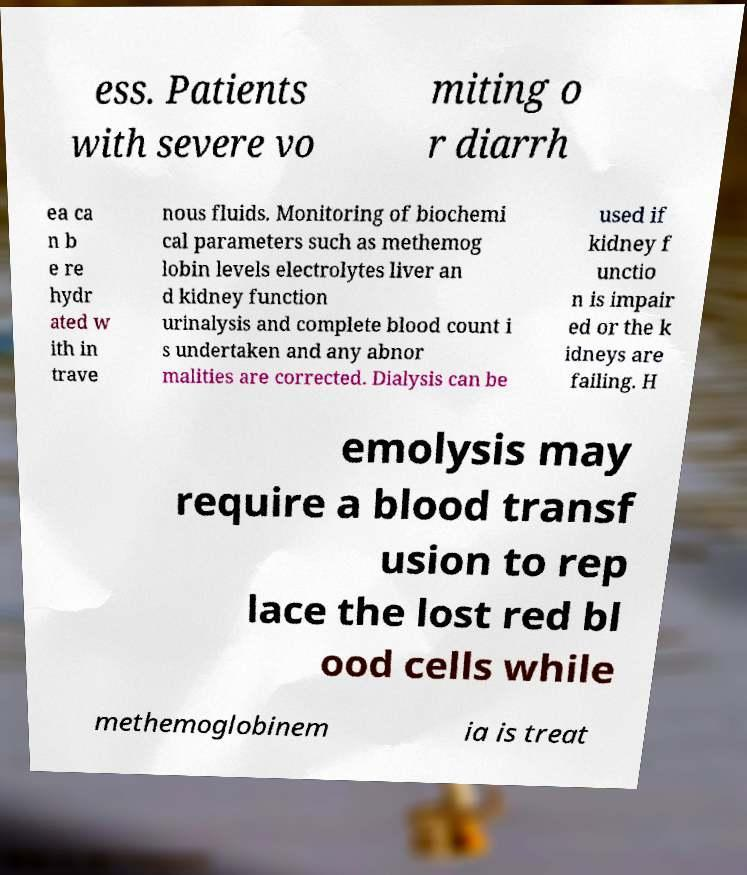What messages or text are displayed in this image? I need them in a readable, typed format. ess. Patients with severe vo miting o r diarrh ea ca n b e re hydr ated w ith in trave nous fluids. Monitoring of biochemi cal parameters such as methemog lobin levels electrolytes liver an d kidney function urinalysis and complete blood count i s undertaken and any abnor malities are corrected. Dialysis can be used if kidney f unctio n is impair ed or the k idneys are failing. H emolysis may require a blood transf usion to rep lace the lost red bl ood cells while methemoglobinem ia is treat 